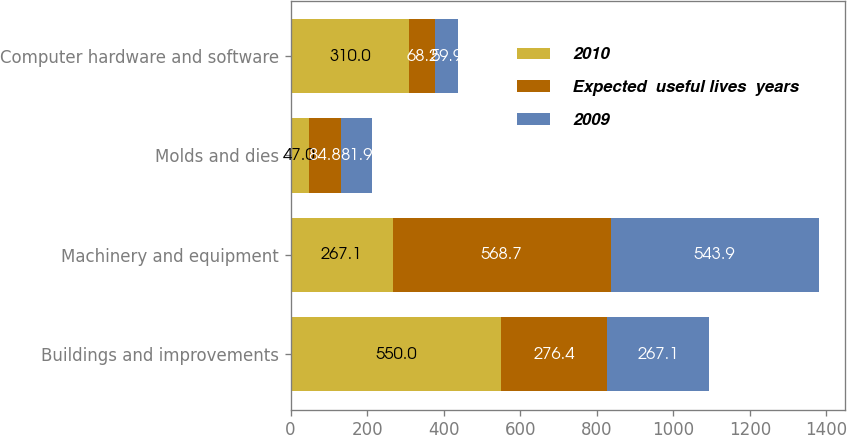<chart> <loc_0><loc_0><loc_500><loc_500><stacked_bar_chart><ecel><fcel>Buildings and improvements<fcel>Machinery and equipment<fcel>Molds and dies<fcel>Computer hardware and software<nl><fcel>2010<fcel>550<fcel>267.1<fcel>47<fcel>310<nl><fcel>Expected  useful lives  years<fcel>276.4<fcel>568.7<fcel>84.8<fcel>68.2<nl><fcel>2009<fcel>267.1<fcel>543.9<fcel>81.9<fcel>59.9<nl></chart> 